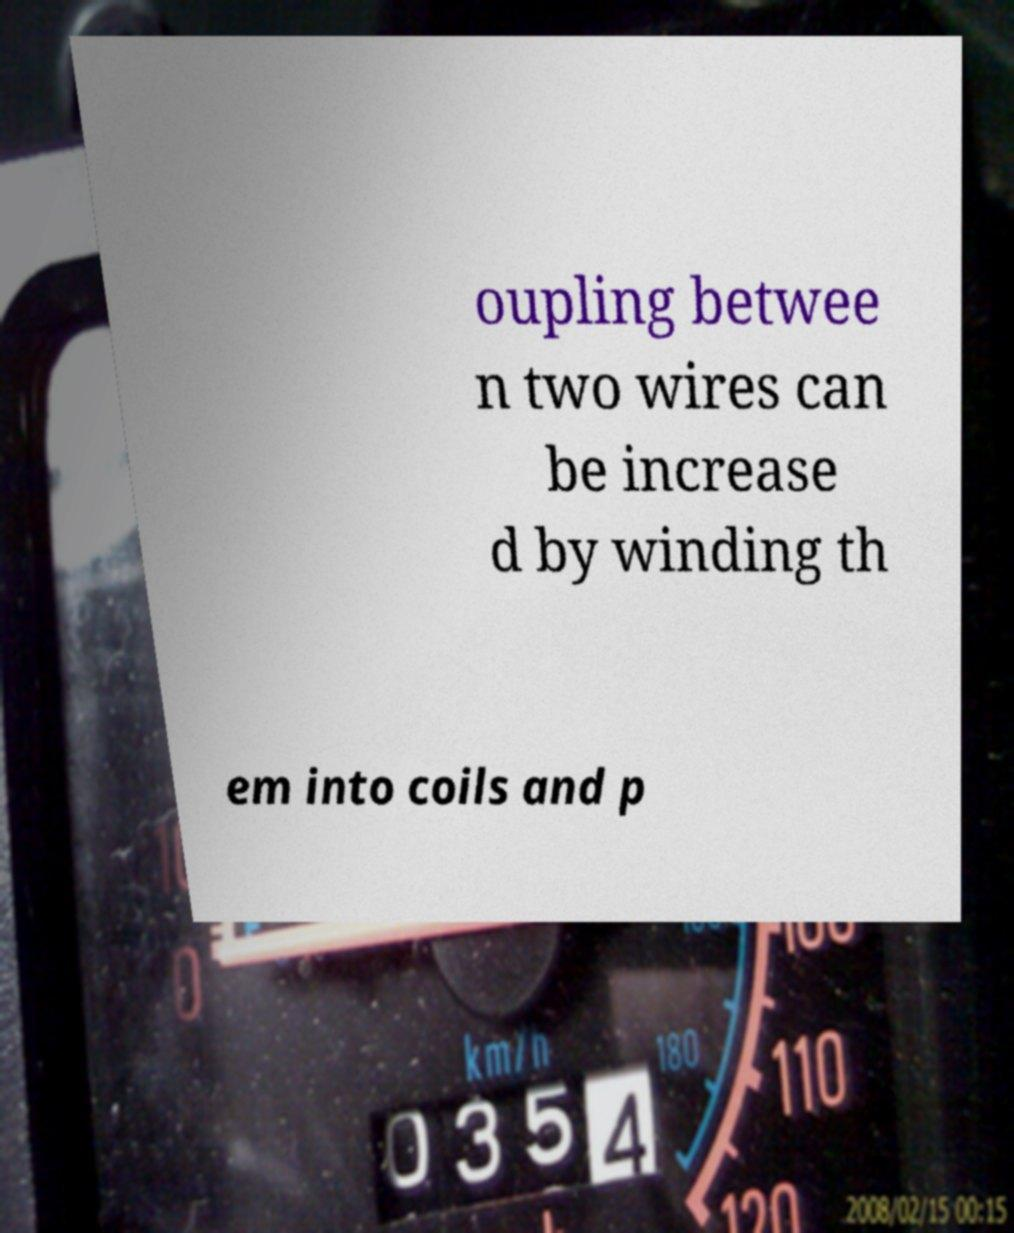What messages or text are displayed in this image? I need them in a readable, typed format. oupling betwee n two wires can be increase d by winding th em into coils and p 